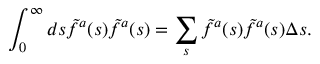Convert formula to latex. <formula><loc_0><loc_0><loc_500><loc_500>\int _ { 0 } ^ { \infty } d s \tilde { f } ^ { a } ( s ) \tilde { f } ^ { a } ( s ) = \sum _ { s } \tilde { f } ^ { a } ( s ) \tilde { f } ^ { a } ( s ) \Delta s .</formula> 